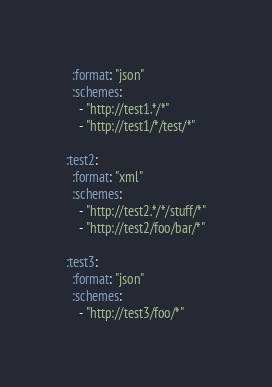Convert code to text. <code><loc_0><loc_0><loc_500><loc_500><_YAML_>  :format: "json"
  :schemes:
    - "http://test1.*/*"
    - "http://test1/*/test/*"

:test2:
  :format: "xml"
  :schemes:
    - "http://test2.*/*/stuff/*"
    - "http://test2/foo/bar/*"

:test3:
  :format: "json"
  :schemes:
    - "http://test3/foo/*"

</code> 